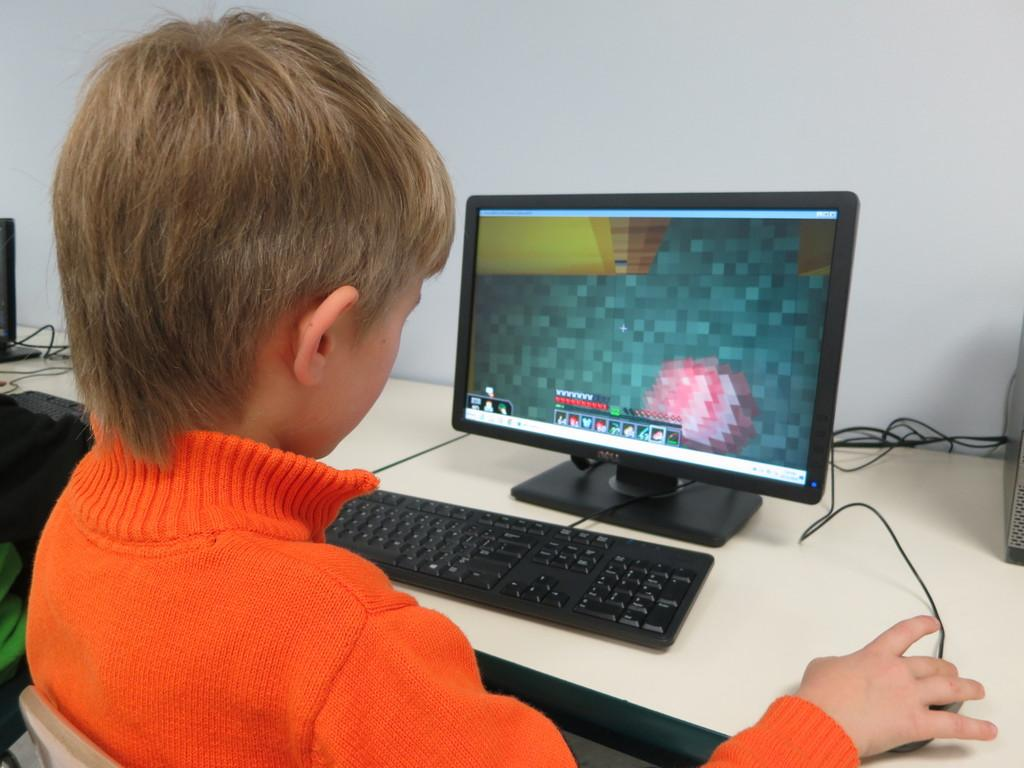<image>
Render a clear and concise summary of the photo. A boy in an orange shirt plays a computer game on a Dell computer 